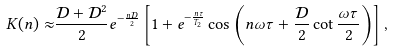Convert formula to latex. <formula><loc_0><loc_0><loc_500><loc_500>K ( n ) \approx & \frac { { \mathcal { D } } + { \mathcal { D } } ^ { 2 } } { 2 } e ^ { - \frac { n { \mathcal { D } } } { 2 } } \left [ 1 + e ^ { - \frac { n \tau } { T _ { 2 } } } \cos \left ( n \omega \tau + \frac { \mathcal { D } } { 2 } \cot \frac { \omega \tau } { 2 } \right ) \right ] ,</formula> 